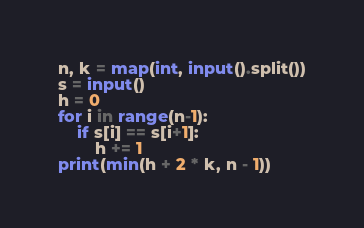<code> <loc_0><loc_0><loc_500><loc_500><_Python_>n, k = map(int, input().split())
s = input()
h = 0
for i in range(n-1):
    if s[i] == s[i+1]:
        h += 1
print(min(h + 2 * k, n - 1))</code> 